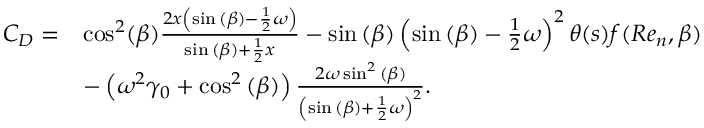Convert formula to latex. <formula><loc_0><loc_0><loc_500><loc_500>\begin{array} { r l } { C _ { D } = } & { \cos ^ { 2 } ( \beta ) \frac { 2 x \left ( \sin { ( \beta ) } - \frac { 1 } { 2 } \omega \right ) } { \sin { ( \beta ) } + \frac { 1 } { 2 } x } - \sin { ( \beta ) } \left ( \sin { ( \beta ) } - \frac { 1 } { 2 } \omega \right ) ^ { 2 } \theta ( s ) f ( R e _ { n } , \beta ) } \\ & { - \left ( \omega ^ { 2 } \gamma _ { 0 } + \cos ^ { 2 } { ( \beta ) } \right ) \frac { 2 \omega \sin ^ { 2 } { ( \beta ) } } { \left ( \sin { ( \beta ) } + \frac { 1 } { 2 } \omega \right ) ^ { 2 } } . } \end{array}</formula> 